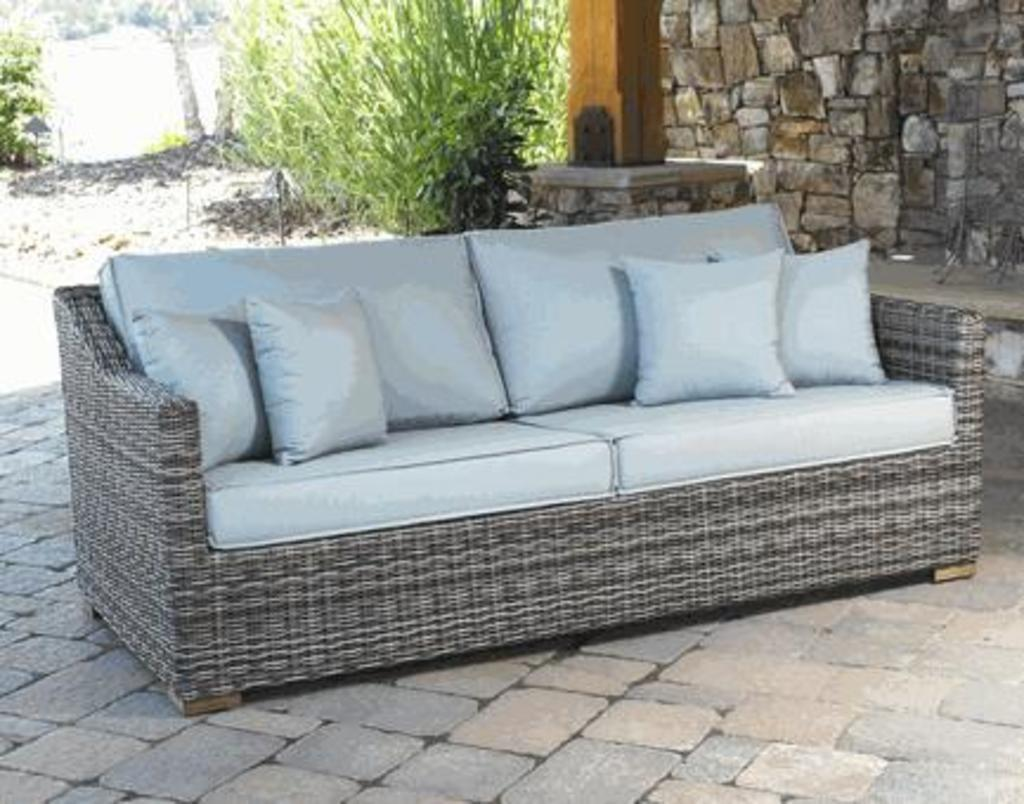What type of furniture is present in the image? There is a sofa with pillows in the image. What can be seen in the background of the image? There are shrubs and a stone wall in the background of the image. What type of wealth is stored in the cellar depicted in the image? There is no cellar present in the image, so it is not possible to determine what type of wealth might be stored there. 